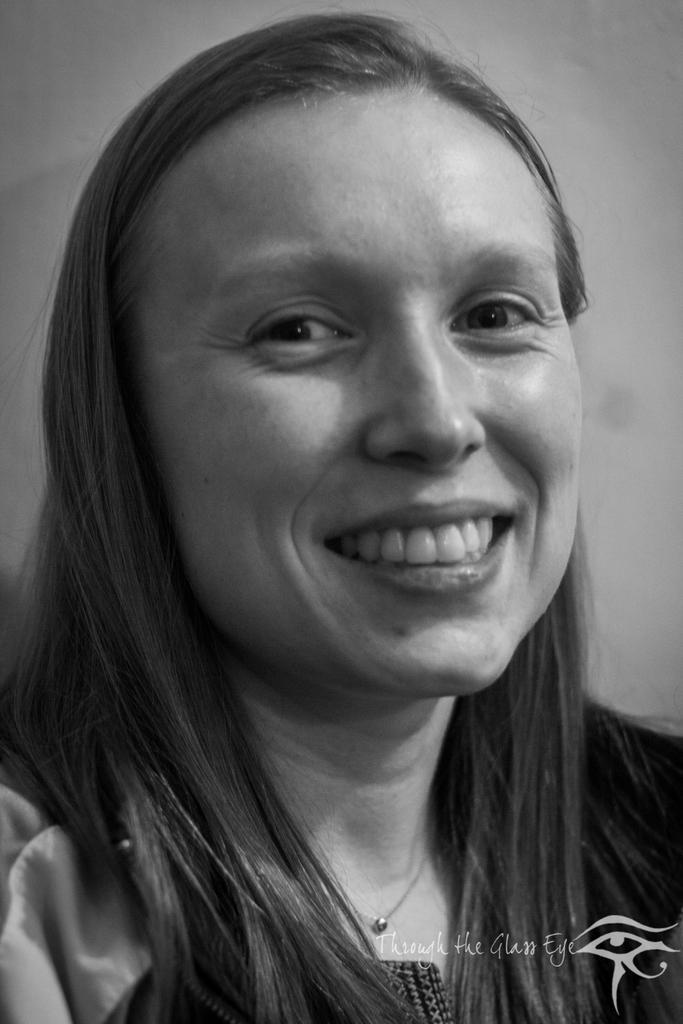Describe this image in one or two sentences. This is a black and white picture of a woman smiling and behind her its a wall. 